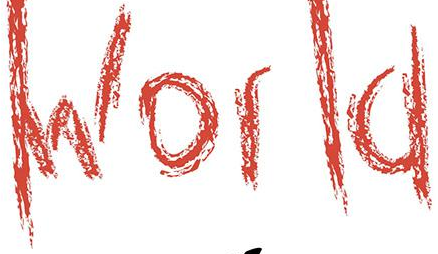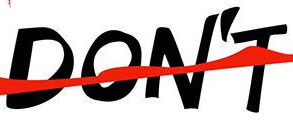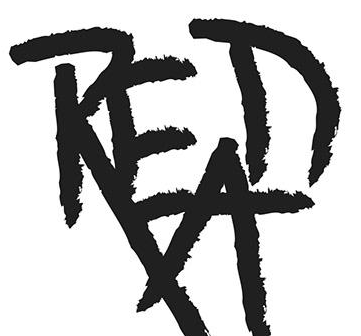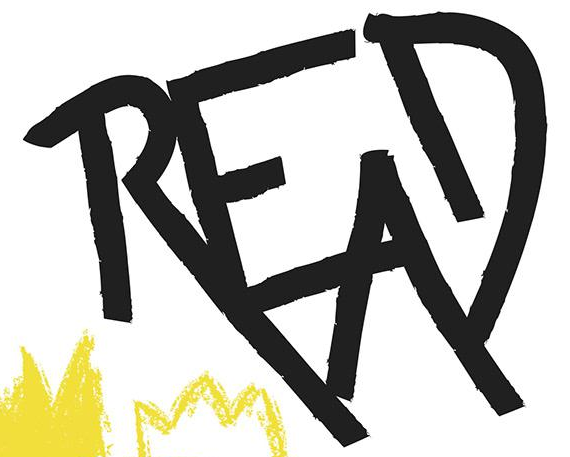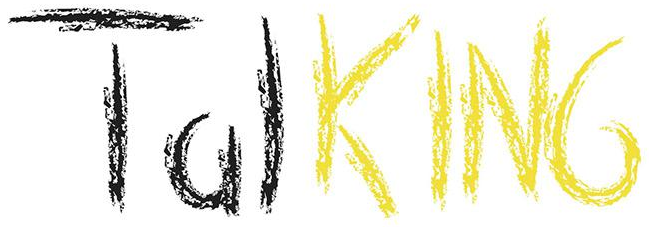What words are shown in these images in order, separated by a semicolon? World; DON'T; READ; READ; TalKING 